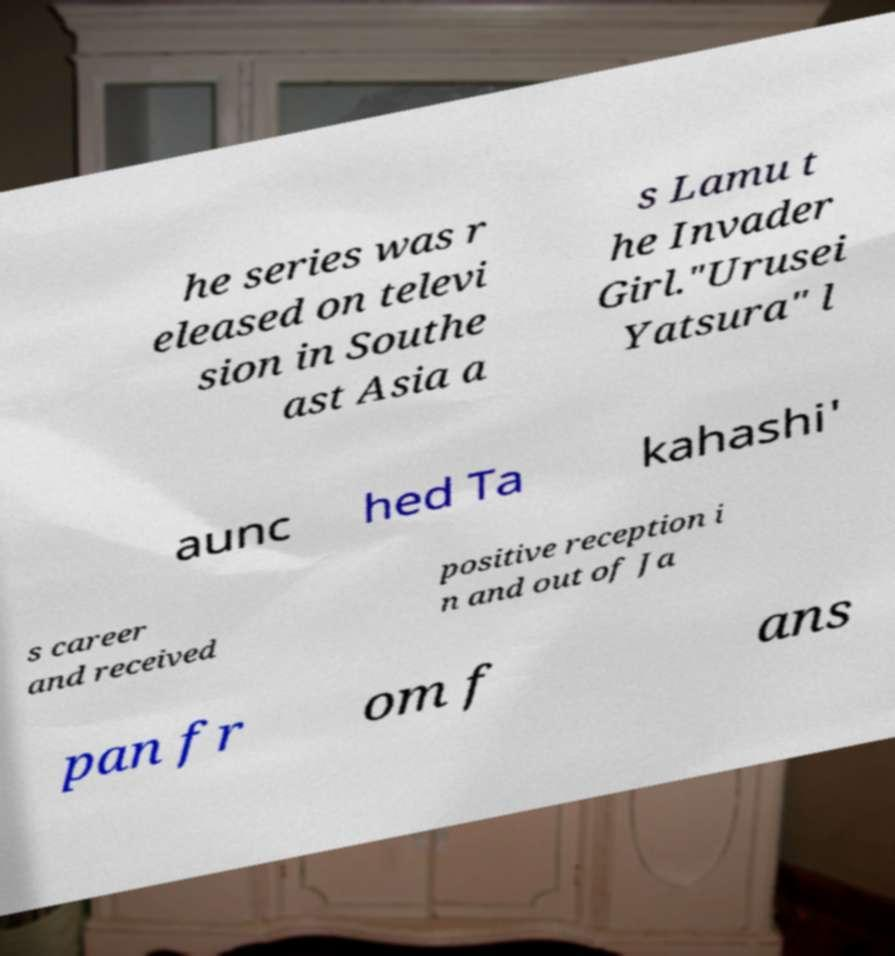Can you read and provide the text displayed in the image?This photo seems to have some interesting text. Can you extract and type it out for me? he series was r eleased on televi sion in Southe ast Asia a s Lamu t he Invader Girl."Urusei Yatsura" l aunc hed Ta kahashi' s career and received positive reception i n and out of Ja pan fr om f ans 